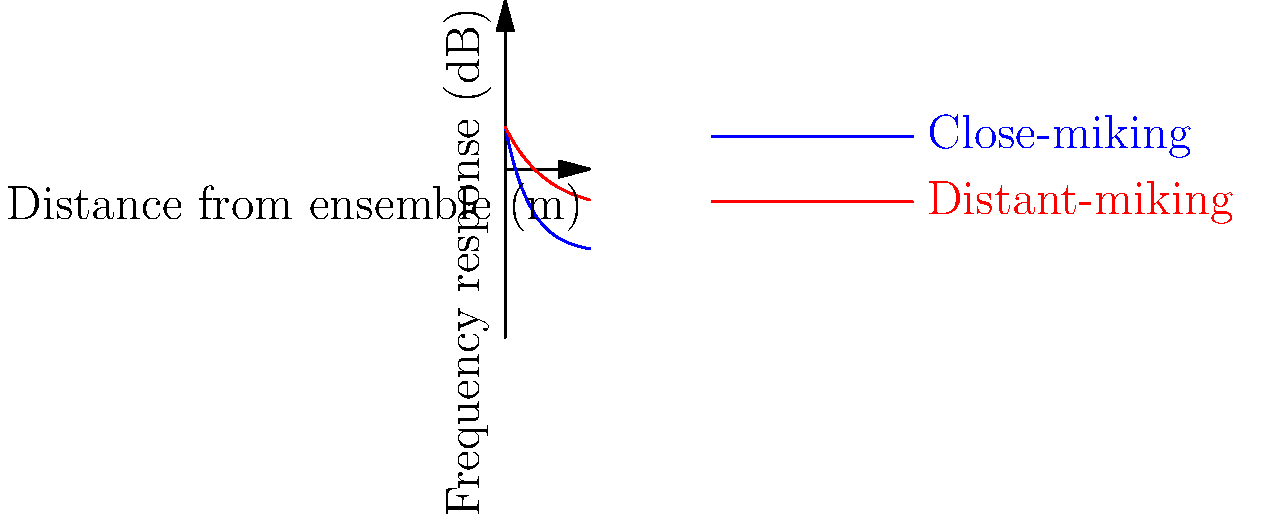Consider the graph showing frequency response curves for close-miking and distant-miking techniques when recording a Renaissance ensemble. Which technique would you recommend to capture the authentic sound of the period, and why? To answer this question, let's analyze the graph and consider the characteristics of Renaissance music:

1. The blue curve represents close-miking, showing a higher initial frequency response that drops off quickly with distance.
2. The red curve represents distant-miking, showing a lower initial frequency response that decays more gradually with distance.

3. Renaissance music characteristics:
   a) Performed in large, reverberant spaces (e.g., cathedrals)
   b) Emphasis on blend and overall ensemble sound rather than individual instruments
   c) Rich in harmonics and overtones

4. Close-miking analysis:
   a) Captures more direct sound from individual instruments
   b) Higher initial frequency response may overemphasize certain instruments
   c) Rapid drop-off in response may not capture room acoustics effectively

5. Distant-miking analysis:
   a) Captures more of the room's natural reverb and acoustics
   b) Lower initial frequency response allows for better blend of instruments
   c) Gradual decay in response mimics the natural sound propagation in large spaces

6. Considering the period-specific aspects:
   a) Distant-miking better replicates the acoustic environment of Renaissance performances
   b) It allows for a more natural blend of instruments, which is crucial for Renaissance ensemble music
   c) The gradual frequency response decay helps capture the rich harmonics and overtones characteristic of the period

Therefore, the distant-miking technique would be more appropriate for capturing the authentic sound of a Renaissance ensemble.
Answer: Distant-miking 